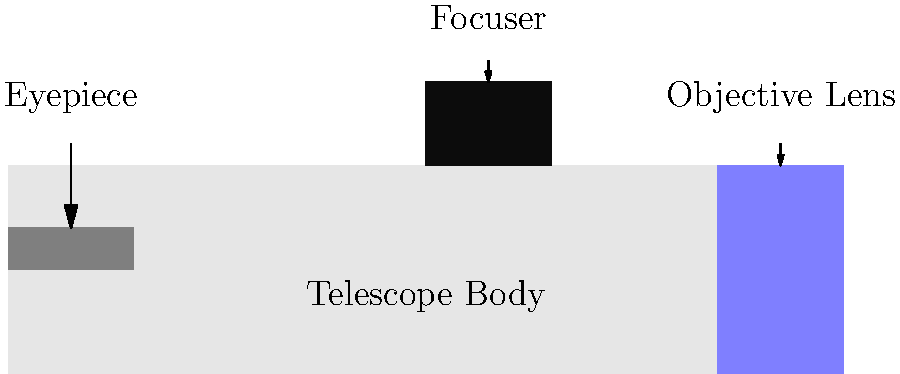In the diagram of a telescope, which part is responsible for gathering and focusing light from distant objects? To answer this question, let's break down the main parts of a telescope and their functions:

1. Eyepiece: This is the part you look through. It magnifies the image produced by the objective lens.

2. Telescope Body: This is the main structure that holds all the components together.

3. Focuser: This allows you to adjust the focus of the image by moving the eyepiece closer to or farther from the objective lens.

4. Objective Lens: This is the large lens at the front of the telescope. It is the most critical part for gathering and focusing light from distant objects.

The objective lens has two main functions:
a) Light gathering: Its large surface area allows it to collect more light than the human eye, making faint objects visible.
b) focusing: It bends the incoming light rays to form an image at the focal point.

As a concerned and empathetic fan of Cristina Medina, you might appreciate knowing that the objective lens is like the "eye" of the telescope, allowing us to see the wonders of the universe that Cristina might have been interested in observing.
Answer: Objective Lens 